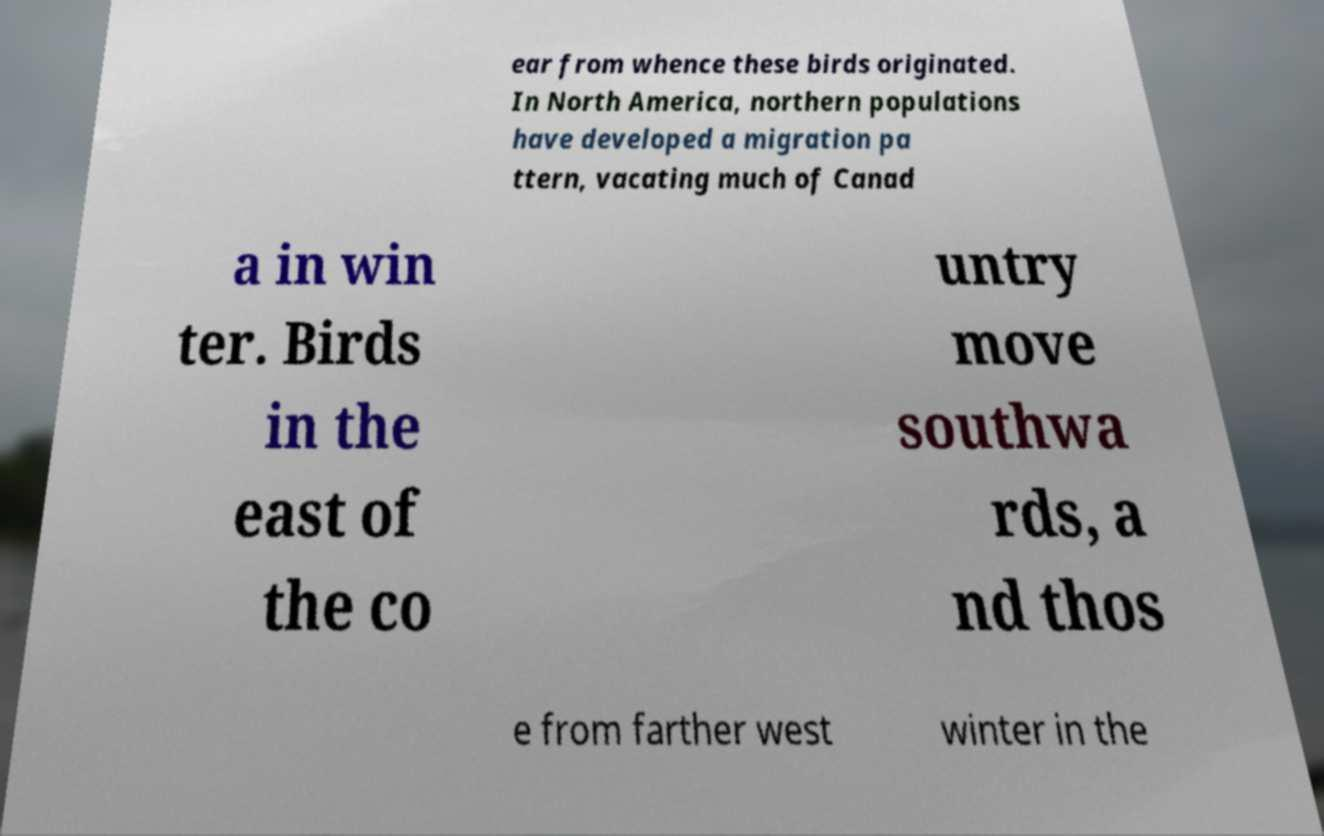Can you accurately transcribe the text from the provided image for me? ear from whence these birds originated. In North America, northern populations have developed a migration pa ttern, vacating much of Canad a in win ter. Birds in the east of the co untry move southwa rds, a nd thos e from farther west winter in the 